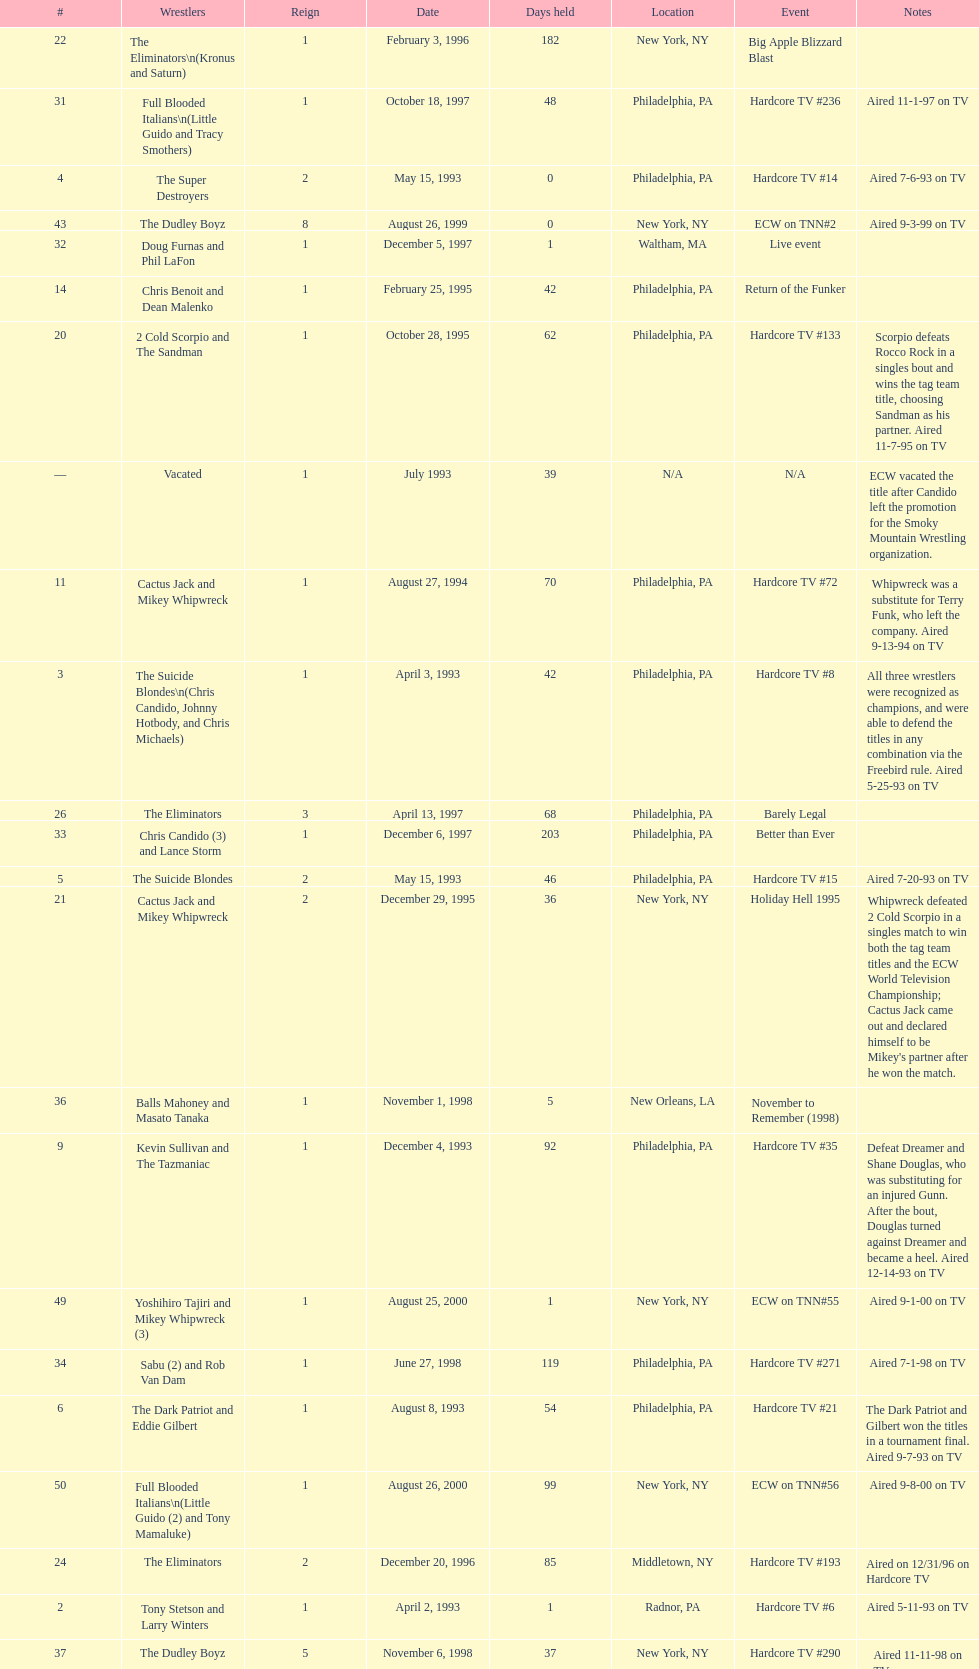What is the next event after hardcore tv #15? Hardcore TV #21. 